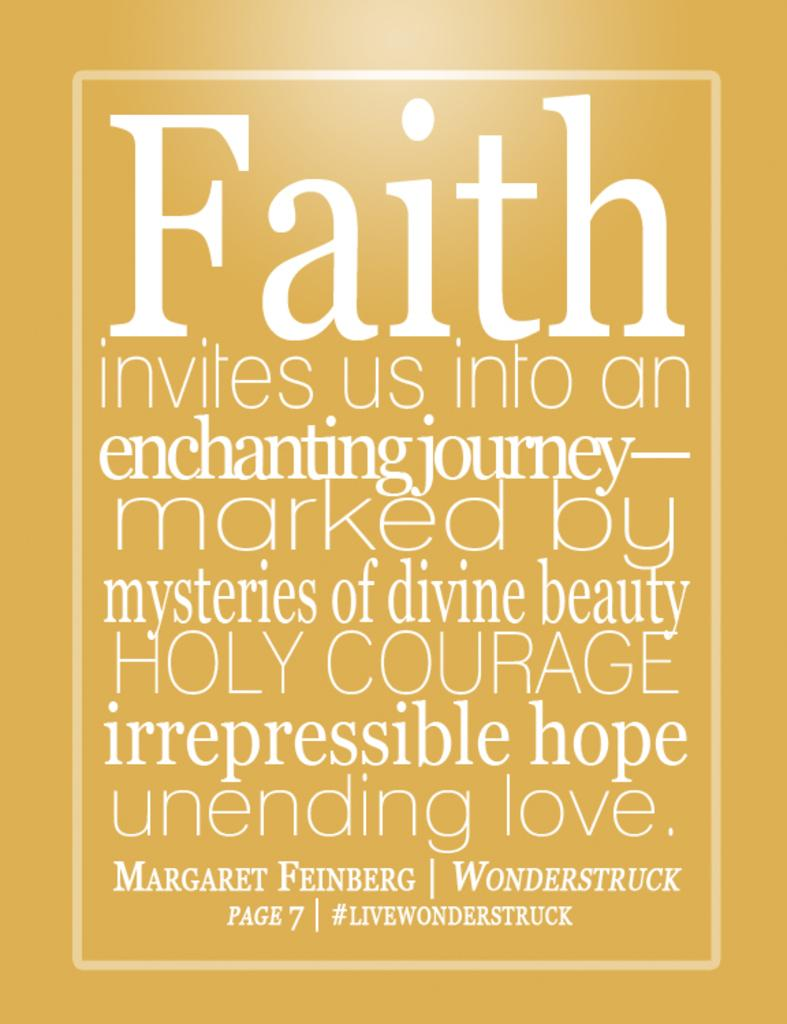<image>
Share a concise interpretation of the image provided. a quote from margaret feinberg is on a yellow poster 